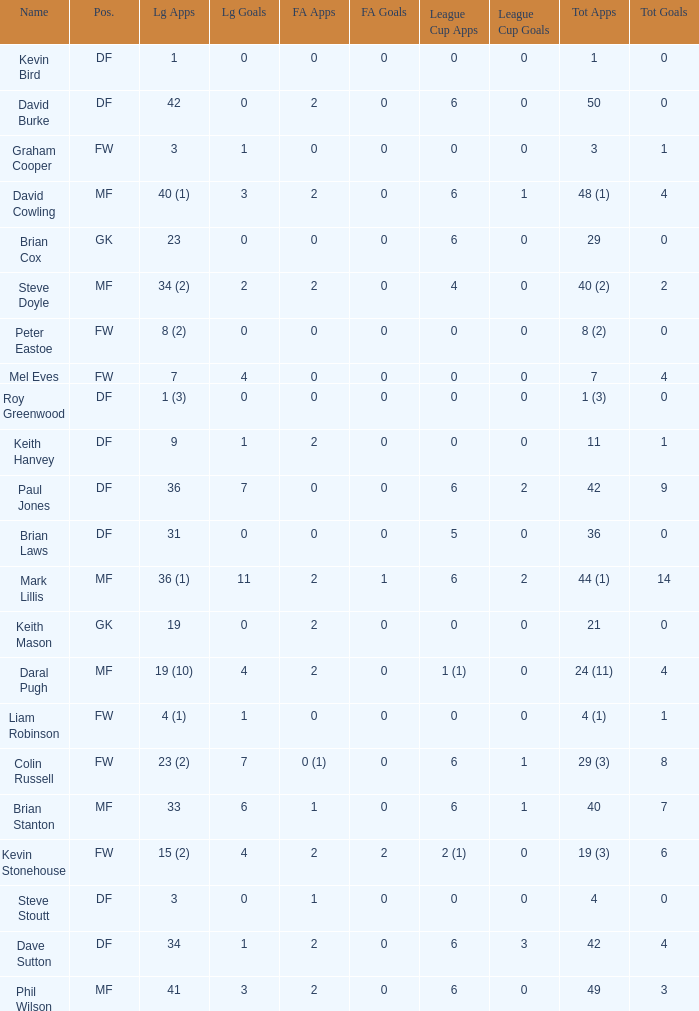What is the most total goals for a player having 0 FA Cup goals and 41 League appearances? 3.0. 